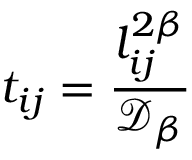<formula> <loc_0><loc_0><loc_500><loc_500>t _ { i j } = \frac { l _ { i j } ^ { 2 \beta } } { \mathcal { D } _ { \beta } }</formula> 